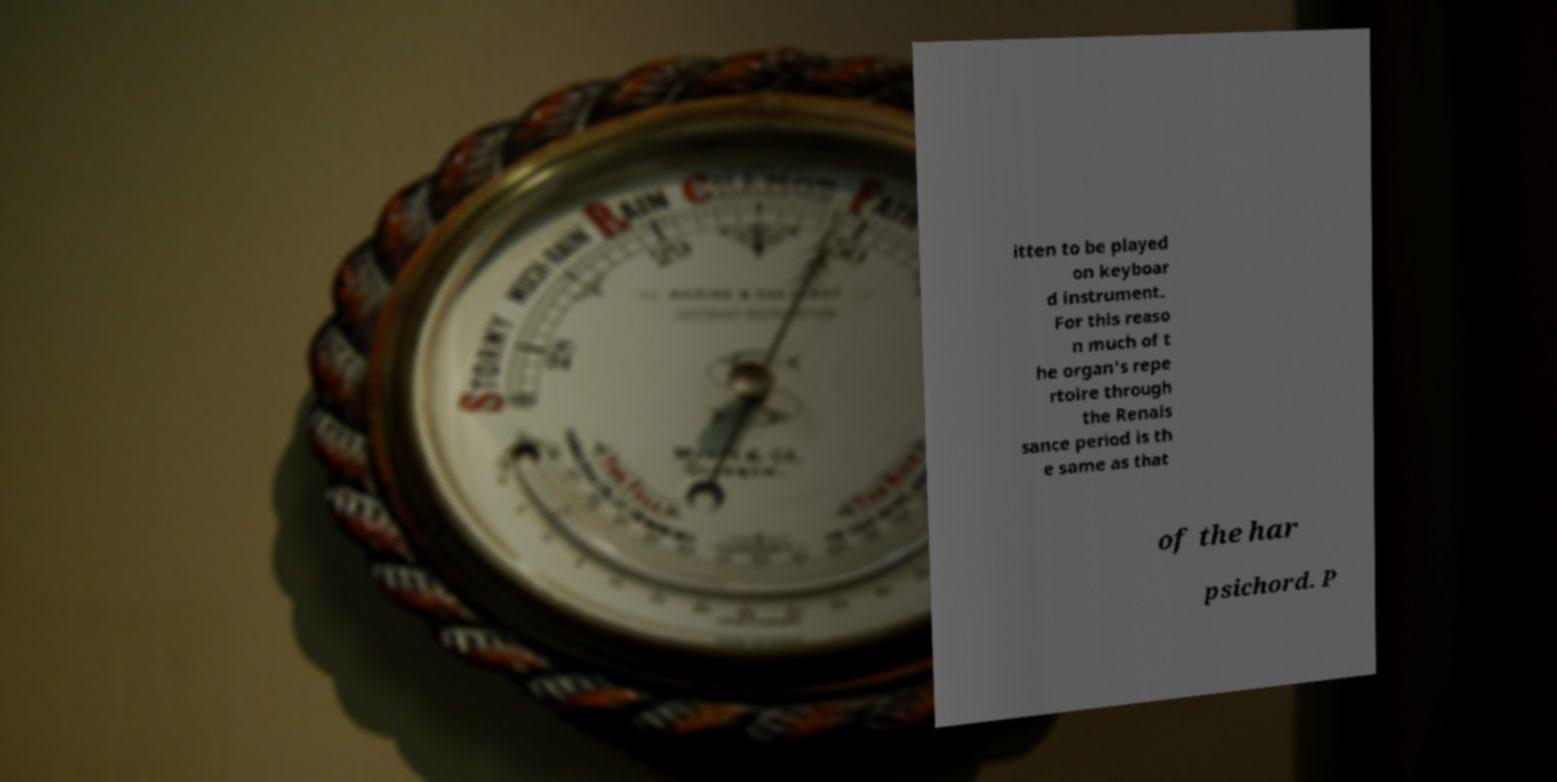For documentation purposes, I need the text within this image transcribed. Could you provide that? itten to be played on keyboar d instrument. For this reaso n much of t he organ's repe rtoire through the Renais sance period is th e same as that of the har psichord. P 